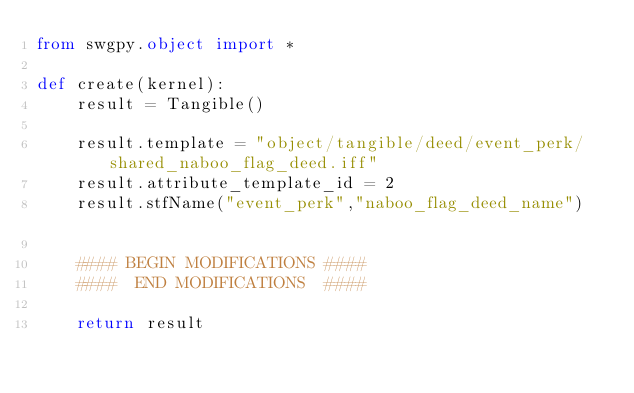<code> <loc_0><loc_0><loc_500><loc_500><_Python_>from swgpy.object import *	

def create(kernel):
	result = Tangible()

	result.template = "object/tangible/deed/event_perk/shared_naboo_flag_deed.iff"
	result.attribute_template_id = 2
	result.stfName("event_perk","naboo_flag_deed_name")		
	
	#### BEGIN MODIFICATIONS ####
	####  END MODIFICATIONS  ####
	
	return result</code> 